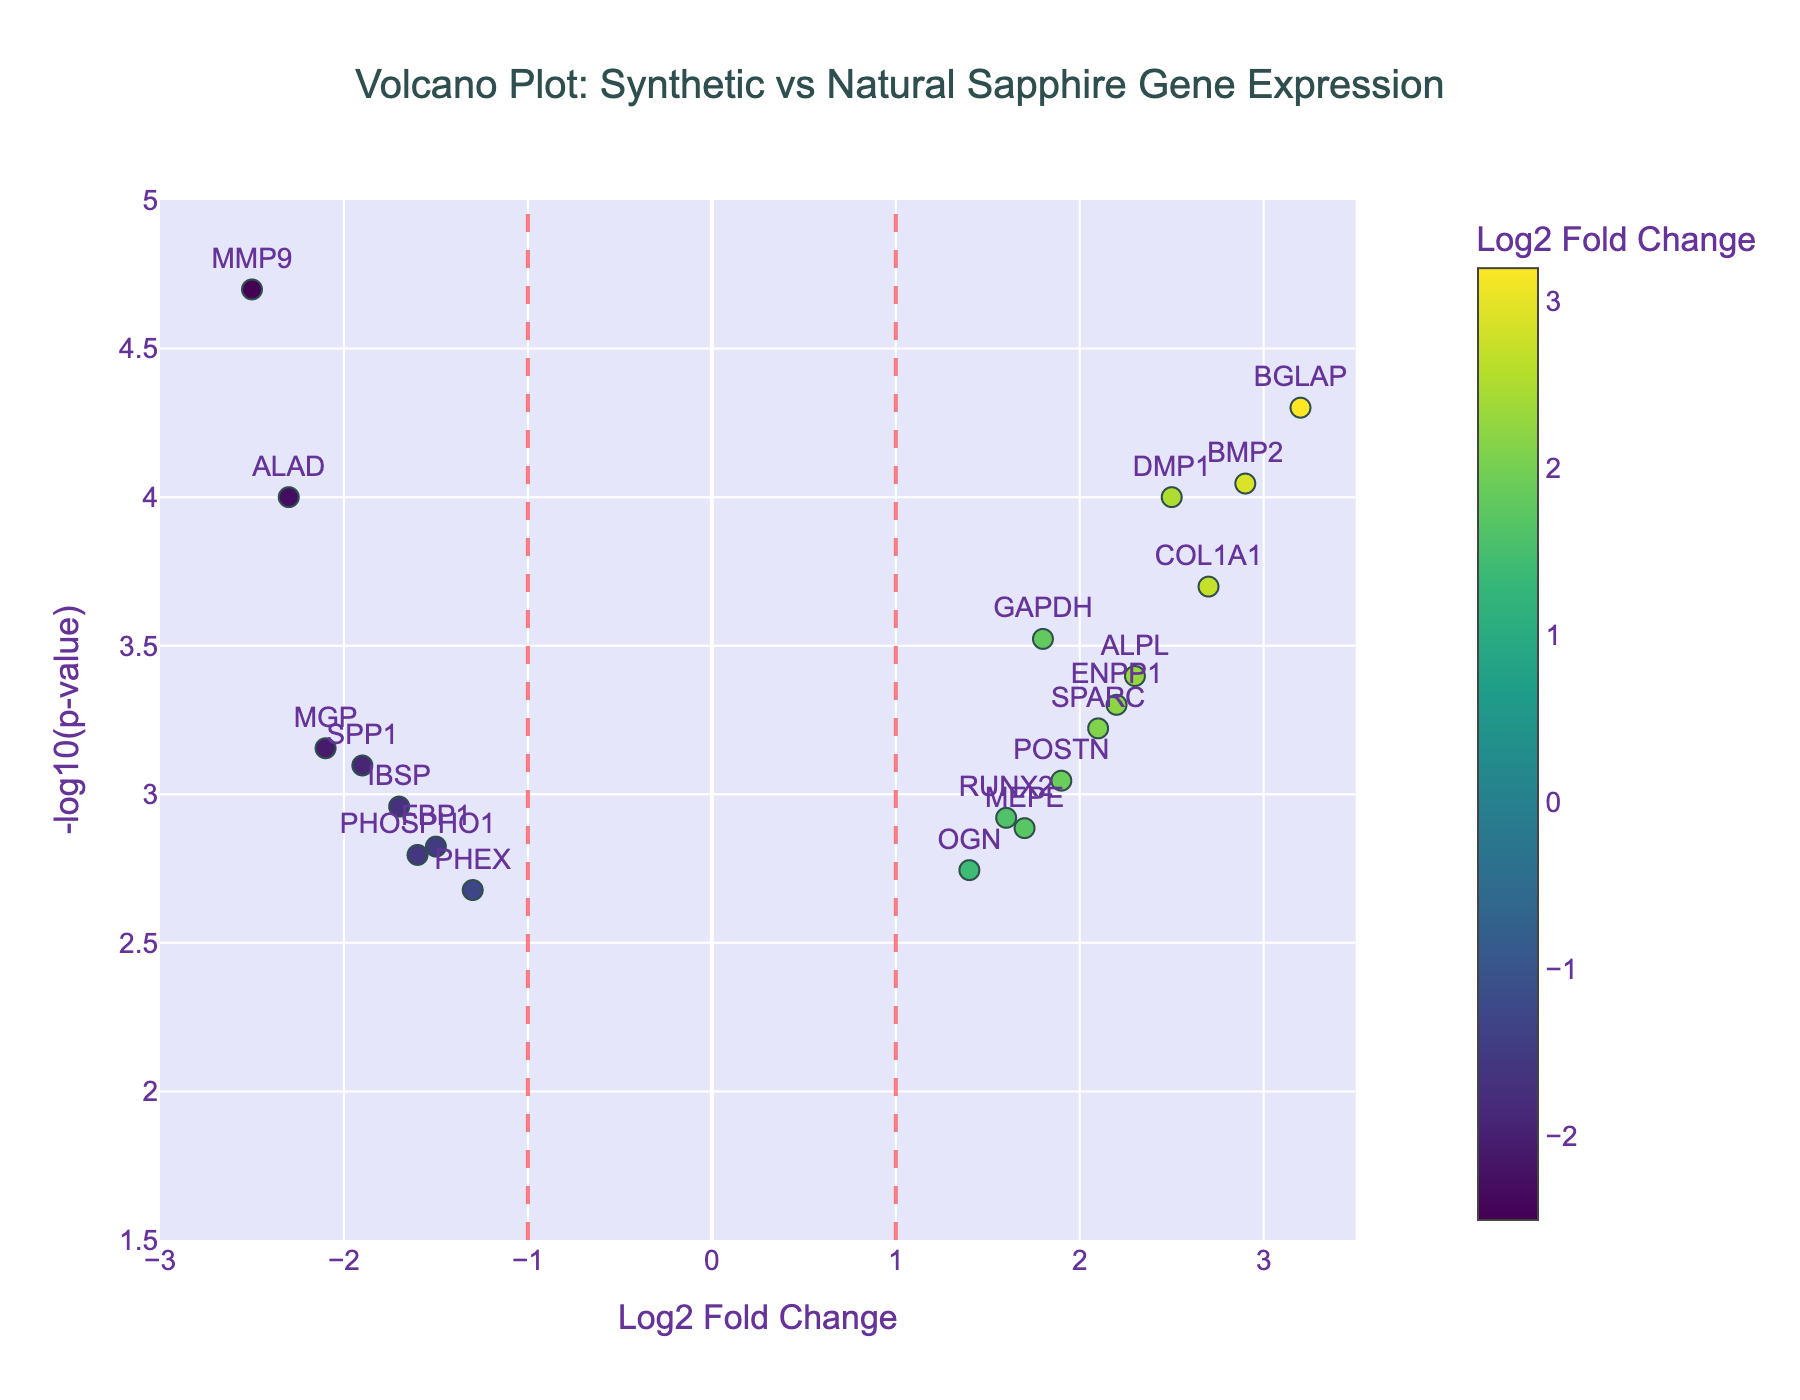What is the title of the plot? The title of the plot is displayed at the top of the figure.
Answer: Volcano Plot: Synthetic vs Natural Sapphire Gene Expression What does the x-axis represent? The label on the x-axis indicates it represents the Log2 Fold Change.
Answer: Log2 Fold Change What does the y-axis represent? The label on the y-axis indicates it represents the -log10(p-value).
Answer: -log10(p-value) How many genes have a Log2 Fold Change between -1 and 1? By looking at the x-axis and locating points between -1 and 1, we count 2 genes within this range.
Answer: 2 Which gene has the highest -log10(p-value)? By finding the point that is the highest on the y-axis, we see that MMP9 has the highest -log10(p-value).
Answer: MMP9 How many genes have a p-value less than 0.0001? The horizontal red dashed line represents p = 0.0001, and we count all points above this line. There are 4 such genes.
Answer: 4 Which gene has the largest positive Log2 Fold Change? By looking for the rightmost point on the x-axis, it is evident that BGLAP has the largest positive Log2 Fold Change.
Answer: BGLAP What is the Log2 Fold Change and p-value of GAPDH? The hover text associated with the GAPDH data point provides this information: Log2 Fold Change is 1.8 and p-value is 0.0003.
Answer: Log2 Fold Change: 1.8, p-value: 0.0003 Which gene lies closest to the origin (0, 0)? The gene closest to the origin can be identified by comparing distances; OGN is closest with coordinates (1.4, approx 2.74).
Answer: OGN 